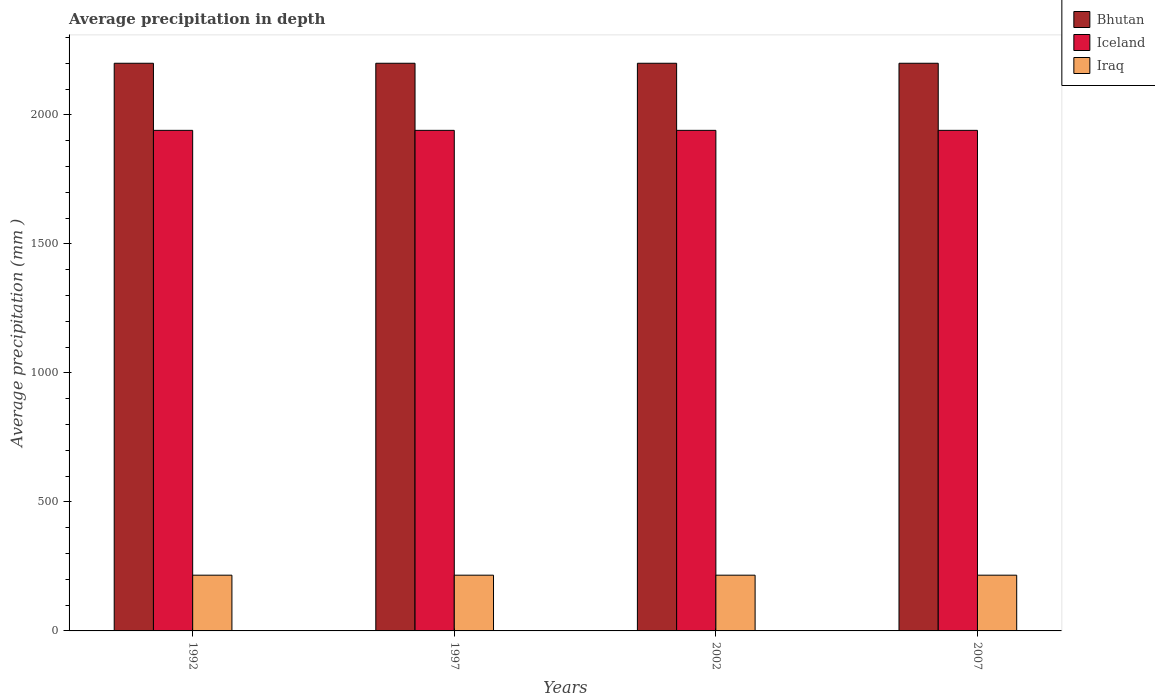How many different coloured bars are there?
Give a very brief answer. 3. Are the number of bars per tick equal to the number of legend labels?
Your response must be concise. Yes. How many bars are there on the 1st tick from the left?
Ensure brevity in your answer.  3. What is the label of the 2nd group of bars from the left?
Make the answer very short. 1997. What is the average precipitation in Bhutan in 2007?
Offer a terse response. 2200. Across all years, what is the maximum average precipitation in Bhutan?
Your answer should be compact. 2200. Across all years, what is the minimum average precipitation in Iraq?
Offer a very short reply. 216. In which year was the average precipitation in Iceland maximum?
Your response must be concise. 1992. In which year was the average precipitation in Iceland minimum?
Offer a very short reply. 1992. What is the total average precipitation in Bhutan in the graph?
Offer a very short reply. 8800. What is the difference between the average precipitation in Iraq in 1997 and that in 2002?
Provide a short and direct response. 0. What is the difference between the average precipitation in Iraq in 1992 and the average precipitation in Bhutan in 2007?
Offer a very short reply. -1984. What is the average average precipitation in Iceland per year?
Provide a succinct answer. 1940. In the year 2007, what is the difference between the average precipitation in Iceland and average precipitation in Bhutan?
Make the answer very short. -260. In how many years, is the average precipitation in Bhutan greater than 2200 mm?
Ensure brevity in your answer.  0. Is the average precipitation in Bhutan in 1992 less than that in 2007?
Your response must be concise. No. What is the difference between the highest and the lowest average precipitation in Iraq?
Your answer should be very brief. 0. What does the 3rd bar from the left in 2002 represents?
Offer a very short reply. Iraq. What does the 3rd bar from the right in 2002 represents?
Provide a short and direct response. Bhutan. Is it the case that in every year, the sum of the average precipitation in Bhutan and average precipitation in Iraq is greater than the average precipitation in Iceland?
Keep it short and to the point. Yes. Are all the bars in the graph horizontal?
Your response must be concise. No. What is the difference between two consecutive major ticks on the Y-axis?
Offer a very short reply. 500. Does the graph contain any zero values?
Your response must be concise. No. How many legend labels are there?
Ensure brevity in your answer.  3. What is the title of the graph?
Your answer should be compact. Average precipitation in depth. Does "World" appear as one of the legend labels in the graph?
Your answer should be compact. No. What is the label or title of the Y-axis?
Keep it short and to the point. Average precipitation (mm ). What is the Average precipitation (mm ) of Bhutan in 1992?
Your response must be concise. 2200. What is the Average precipitation (mm ) in Iceland in 1992?
Ensure brevity in your answer.  1940. What is the Average precipitation (mm ) of Iraq in 1992?
Provide a succinct answer. 216. What is the Average precipitation (mm ) in Bhutan in 1997?
Ensure brevity in your answer.  2200. What is the Average precipitation (mm ) in Iceland in 1997?
Provide a short and direct response. 1940. What is the Average precipitation (mm ) of Iraq in 1997?
Give a very brief answer. 216. What is the Average precipitation (mm ) of Bhutan in 2002?
Keep it short and to the point. 2200. What is the Average precipitation (mm ) in Iceland in 2002?
Provide a succinct answer. 1940. What is the Average precipitation (mm ) of Iraq in 2002?
Make the answer very short. 216. What is the Average precipitation (mm ) of Bhutan in 2007?
Your response must be concise. 2200. What is the Average precipitation (mm ) in Iceland in 2007?
Provide a succinct answer. 1940. What is the Average precipitation (mm ) in Iraq in 2007?
Offer a terse response. 216. Across all years, what is the maximum Average precipitation (mm ) of Bhutan?
Ensure brevity in your answer.  2200. Across all years, what is the maximum Average precipitation (mm ) in Iceland?
Provide a succinct answer. 1940. Across all years, what is the maximum Average precipitation (mm ) of Iraq?
Your answer should be very brief. 216. Across all years, what is the minimum Average precipitation (mm ) of Bhutan?
Offer a terse response. 2200. Across all years, what is the minimum Average precipitation (mm ) of Iceland?
Make the answer very short. 1940. Across all years, what is the minimum Average precipitation (mm ) of Iraq?
Offer a very short reply. 216. What is the total Average precipitation (mm ) of Bhutan in the graph?
Your answer should be compact. 8800. What is the total Average precipitation (mm ) of Iceland in the graph?
Your response must be concise. 7760. What is the total Average precipitation (mm ) of Iraq in the graph?
Your answer should be very brief. 864. What is the difference between the Average precipitation (mm ) of Bhutan in 1992 and that in 1997?
Offer a very short reply. 0. What is the difference between the Average precipitation (mm ) in Iraq in 1992 and that in 1997?
Keep it short and to the point. 0. What is the difference between the Average precipitation (mm ) in Bhutan in 1992 and that in 2002?
Your answer should be very brief. 0. What is the difference between the Average precipitation (mm ) in Iceland in 1992 and that in 2002?
Provide a succinct answer. 0. What is the difference between the Average precipitation (mm ) in Iceland in 1992 and that in 2007?
Give a very brief answer. 0. What is the difference between the Average precipitation (mm ) in Iraq in 1992 and that in 2007?
Provide a short and direct response. 0. What is the difference between the Average precipitation (mm ) of Iceland in 1997 and that in 2002?
Keep it short and to the point. 0. What is the difference between the Average precipitation (mm ) in Bhutan in 1997 and that in 2007?
Your answer should be very brief. 0. What is the difference between the Average precipitation (mm ) of Iceland in 1997 and that in 2007?
Provide a succinct answer. 0. What is the difference between the Average precipitation (mm ) of Iraq in 2002 and that in 2007?
Your response must be concise. 0. What is the difference between the Average precipitation (mm ) of Bhutan in 1992 and the Average precipitation (mm ) of Iceland in 1997?
Make the answer very short. 260. What is the difference between the Average precipitation (mm ) of Bhutan in 1992 and the Average precipitation (mm ) of Iraq in 1997?
Offer a very short reply. 1984. What is the difference between the Average precipitation (mm ) in Iceland in 1992 and the Average precipitation (mm ) in Iraq in 1997?
Provide a short and direct response. 1724. What is the difference between the Average precipitation (mm ) of Bhutan in 1992 and the Average precipitation (mm ) of Iceland in 2002?
Provide a short and direct response. 260. What is the difference between the Average precipitation (mm ) of Bhutan in 1992 and the Average precipitation (mm ) of Iraq in 2002?
Ensure brevity in your answer.  1984. What is the difference between the Average precipitation (mm ) in Iceland in 1992 and the Average precipitation (mm ) in Iraq in 2002?
Offer a very short reply. 1724. What is the difference between the Average precipitation (mm ) in Bhutan in 1992 and the Average precipitation (mm ) in Iceland in 2007?
Your response must be concise. 260. What is the difference between the Average precipitation (mm ) of Bhutan in 1992 and the Average precipitation (mm ) of Iraq in 2007?
Your response must be concise. 1984. What is the difference between the Average precipitation (mm ) of Iceland in 1992 and the Average precipitation (mm ) of Iraq in 2007?
Give a very brief answer. 1724. What is the difference between the Average precipitation (mm ) in Bhutan in 1997 and the Average precipitation (mm ) in Iceland in 2002?
Offer a very short reply. 260. What is the difference between the Average precipitation (mm ) in Bhutan in 1997 and the Average precipitation (mm ) in Iraq in 2002?
Give a very brief answer. 1984. What is the difference between the Average precipitation (mm ) of Iceland in 1997 and the Average precipitation (mm ) of Iraq in 2002?
Ensure brevity in your answer.  1724. What is the difference between the Average precipitation (mm ) in Bhutan in 1997 and the Average precipitation (mm ) in Iceland in 2007?
Your answer should be compact. 260. What is the difference between the Average precipitation (mm ) of Bhutan in 1997 and the Average precipitation (mm ) of Iraq in 2007?
Give a very brief answer. 1984. What is the difference between the Average precipitation (mm ) of Iceland in 1997 and the Average precipitation (mm ) of Iraq in 2007?
Offer a very short reply. 1724. What is the difference between the Average precipitation (mm ) in Bhutan in 2002 and the Average precipitation (mm ) in Iceland in 2007?
Provide a short and direct response. 260. What is the difference between the Average precipitation (mm ) of Bhutan in 2002 and the Average precipitation (mm ) of Iraq in 2007?
Offer a terse response. 1984. What is the difference between the Average precipitation (mm ) of Iceland in 2002 and the Average precipitation (mm ) of Iraq in 2007?
Your answer should be very brief. 1724. What is the average Average precipitation (mm ) of Bhutan per year?
Make the answer very short. 2200. What is the average Average precipitation (mm ) in Iceland per year?
Ensure brevity in your answer.  1940. What is the average Average precipitation (mm ) in Iraq per year?
Offer a terse response. 216. In the year 1992, what is the difference between the Average precipitation (mm ) in Bhutan and Average precipitation (mm ) in Iceland?
Ensure brevity in your answer.  260. In the year 1992, what is the difference between the Average precipitation (mm ) in Bhutan and Average precipitation (mm ) in Iraq?
Offer a terse response. 1984. In the year 1992, what is the difference between the Average precipitation (mm ) in Iceland and Average precipitation (mm ) in Iraq?
Your response must be concise. 1724. In the year 1997, what is the difference between the Average precipitation (mm ) of Bhutan and Average precipitation (mm ) of Iceland?
Ensure brevity in your answer.  260. In the year 1997, what is the difference between the Average precipitation (mm ) of Bhutan and Average precipitation (mm ) of Iraq?
Give a very brief answer. 1984. In the year 1997, what is the difference between the Average precipitation (mm ) of Iceland and Average precipitation (mm ) of Iraq?
Offer a very short reply. 1724. In the year 2002, what is the difference between the Average precipitation (mm ) of Bhutan and Average precipitation (mm ) of Iceland?
Offer a very short reply. 260. In the year 2002, what is the difference between the Average precipitation (mm ) in Bhutan and Average precipitation (mm ) in Iraq?
Give a very brief answer. 1984. In the year 2002, what is the difference between the Average precipitation (mm ) in Iceland and Average precipitation (mm ) in Iraq?
Your response must be concise. 1724. In the year 2007, what is the difference between the Average precipitation (mm ) in Bhutan and Average precipitation (mm ) in Iceland?
Keep it short and to the point. 260. In the year 2007, what is the difference between the Average precipitation (mm ) in Bhutan and Average precipitation (mm ) in Iraq?
Make the answer very short. 1984. In the year 2007, what is the difference between the Average precipitation (mm ) in Iceland and Average precipitation (mm ) in Iraq?
Your response must be concise. 1724. What is the ratio of the Average precipitation (mm ) in Bhutan in 1992 to that in 2002?
Your response must be concise. 1. What is the ratio of the Average precipitation (mm ) of Iceland in 1992 to that in 2002?
Offer a terse response. 1. What is the ratio of the Average precipitation (mm ) of Iraq in 1992 to that in 2002?
Your response must be concise. 1. What is the ratio of the Average precipitation (mm ) of Bhutan in 1992 to that in 2007?
Offer a terse response. 1. What is the ratio of the Average precipitation (mm ) of Iceland in 1992 to that in 2007?
Offer a terse response. 1. What is the ratio of the Average precipitation (mm ) in Iraq in 1992 to that in 2007?
Keep it short and to the point. 1. What is the ratio of the Average precipitation (mm ) of Bhutan in 1997 to that in 2002?
Your answer should be very brief. 1. What is the ratio of the Average precipitation (mm ) of Iceland in 1997 to that in 2002?
Offer a very short reply. 1. What is the ratio of the Average precipitation (mm ) in Iraq in 1997 to that in 2002?
Offer a terse response. 1. What is the ratio of the Average precipitation (mm ) of Bhutan in 1997 to that in 2007?
Provide a succinct answer. 1. What is the ratio of the Average precipitation (mm ) in Iceland in 1997 to that in 2007?
Provide a succinct answer. 1. What is the ratio of the Average precipitation (mm ) of Bhutan in 2002 to that in 2007?
Offer a terse response. 1. What is the ratio of the Average precipitation (mm ) of Iceland in 2002 to that in 2007?
Keep it short and to the point. 1. What is the difference between the highest and the second highest Average precipitation (mm ) of Iraq?
Your answer should be very brief. 0. What is the difference between the highest and the lowest Average precipitation (mm ) of Iceland?
Provide a short and direct response. 0. 